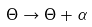<formula> <loc_0><loc_0><loc_500><loc_500>\Theta \rightarrow \Theta + \alpha</formula> 